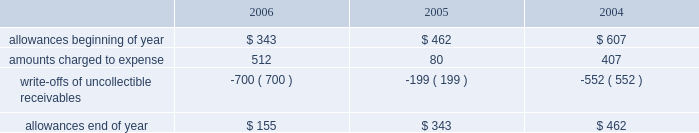Goodwill is reviewed annually during the fourth quarter for impairment .
In addition , the company performs an impairment analysis of other intangible assets based on the occurrence of other factors .
Such factors include , but are not limited to , significant changes in membership , state funding , medical contracts and provider networks and contracts .
An impairment loss is recognized if the carrying value of intangible assets exceeds the implied fair value .
Medical claims liabilities medical services costs include claims paid , claims reported but not yet paid , or inventory , estimates for claims incurred but not yet received , or ibnr , and estimates for the costs necessary to process unpaid claims .
The estimates of medical claims liabilities are developed using standard actuarial methods based upon historical data for payment patterns , cost trends , product mix , sea- sonality , utilization of healthcare services and other rele- vant factors including product changes .
These estimates are continually reviewed and adjustments , if necessary , are reflected in the period known .
Management did not change actuarial methods during the years presented .
Management believes the amount of medical claims payable is reasonable and adequate to cover the company 2019s liability for unpaid claims as of december 31 , 2006 ; however , actual claim payments may differ from established estimates .
Revenue recognition the company 2019s medicaid managed care segment gener- ates revenues primarily from premiums received from the states in which it operates health plans .
The company receives a fixed premium per member per month pursuant to our state contracts .
The company generally receives premium payments during the month it provides services and recognizes premium revenue during the period in which it is obligated to provide services to its members .
Some states enact premium taxes or similar assessments , collectively premium taxes , and these taxes are recorded as general and administrative expenses .
Some contracts allow for additional premium related to certain supplemen- tal services provided such as maternity deliveries .
Revenues are recorded based on membership and eligibility data provided by the states , which may be adjusted by the states for updates to this data .
These adjustments have been immaterial in relation to total revenue recorded and are reflected in the period known .
The company 2019s specialty services segment generates revenues under contracts with state programs , healthcare organizations and other commercial organizations , as well as from our own subsidiaries on market-based terms .
Revenues are recognized when the related services are provided or as ratably earned over the covered period of service .
Premium and services revenues collected in advance are recorded as unearned revenue .
For performance-based contracts the company does not recognize revenue subject to refund until data is sufficient to measure performance .
Premiums and service revenues due to the company are recorded as premium and related receivables and are recorded net of an allowance based on historical trends and management 2019s judgment on the collectibility of these accounts .
As the company generally receives payments during the month in which services are provided , the allowance is typically not significant in comparison to total revenues and does not have a material impact on the pres- entation of the financial condition or results of operations .
Activity in the allowance for uncollectible accounts for the years ended december 31 is summarized below: .
Significant customers centene receives the majority of its revenues under con- tracts or subcontracts with state medicaid managed care programs .
The contracts , which expire on various dates between june 30 , 2007 and december 31 , 2011 , are expected to be renewed .
Contracts with the states of georgia , indiana , kansas , texas and wisconsin each accounted for 15% ( 15 % ) , 15% ( 15 % ) , 10% ( 10 % ) , 17% ( 17 % ) and 16% ( 16 % ) , respectively , of the company 2019s revenues for the year ended december 31 , 2006 .
Reinsurance centene has purchased reinsurance from third parties to cover eligible healthcare services .
The current reinsurance program covers 90% ( 90 % ) of inpatient healthcare expenses in excess of annual deductibles of $ 300 to $ 500 per member , up to an annual maximum of $ 2000 .
Centene 2019s medicaid managed care subsidiaries are responsible for inpatient charges in excess of an average daily per diem .
In addition , bridgeway participates in a risk-sharing program as part of its contract with the state of arizona for the reimbursement of certain contract service costs beyond a monetary threshold .
Reinsurance recoveries were $ 3674 , $ 4014 , and $ 3730 , in 2006 , 2005 , and 2004 , respectively .
Reinsurance expenses were approximately $ 4842 , $ 4105 , and $ 6724 in 2006 , 2005 , and 2004 , respectively .
Reinsurance recoveries , net of expenses , are included in medical costs .
Other income ( expense ) other income ( expense ) consists principally of investment income and interest expense .
Investment income is derived from the company 2019s cash , cash equivalents , restricted deposits and investments. .
What was the percentage change in year end allowance for uncollectible accounts between 2004 and 2005? 
Computations: ((343 - 462) / 462)
Answer: -0.25758. 